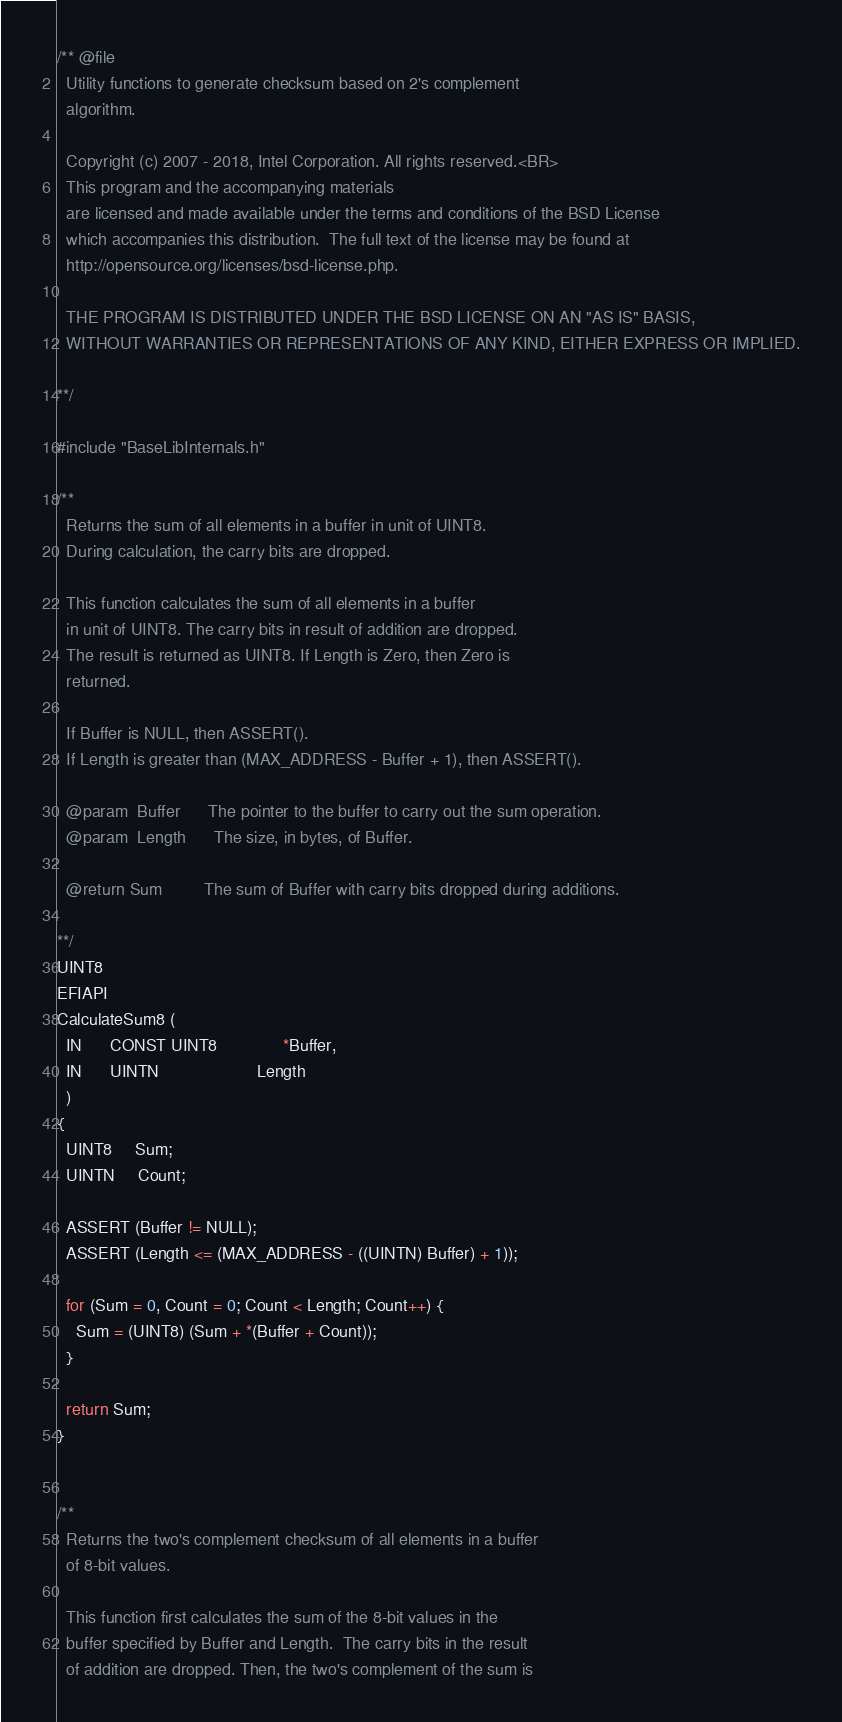<code> <loc_0><loc_0><loc_500><loc_500><_C_>/** @file
  Utility functions to generate checksum based on 2's complement
  algorithm.

  Copyright (c) 2007 - 2018, Intel Corporation. All rights reserved.<BR>
  This program and the accompanying materials
  are licensed and made available under the terms and conditions of the BSD License
  which accompanies this distribution.  The full text of the license may be found at
  http://opensource.org/licenses/bsd-license.php.

  THE PROGRAM IS DISTRIBUTED UNDER THE BSD LICENSE ON AN "AS IS" BASIS,
  WITHOUT WARRANTIES OR REPRESENTATIONS OF ANY KIND, EITHER EXPRESS OR IMPLIED.

**/

#include "BaseLibInternals.h"

/**
  Returns the sum of all elements in a buffer in unit of UINT8.
  During calculation, the carry bits are dropped.

  This function calculates the sum of all elements in a buffer
  in unit of UINT8. The carry bits in result of addition are dropped.
  The result is returned as UINT8. If Length is Zero, then Zero is
  returned.

  If Buffer is NULL, then ASSERT().
  If Length is greater than (MAX_ADDRESS - Buffer + 1), then ASSERT().

  @param  Buffer      The pointer to the buffer to carry out the sum operation.
  @param  Length      The size, in bytes, of Buffer.

  @return Sum         The sum of Buffer with carry bits dropped during additions.

**/
UINT8
EFIAPI
CalculateSum8 (
  IN      CONST UINT8              *Buffer,
  IN      UINTN                     Length
  )
{
  UINT8     Sum;
  UINTN     Count;

  ASSERT (Buffer != NULL);
  ASSERT (Length <= (MAX_ADDRESS - ((UINTN) Buffer) + 1));

  for (Sum = 0, Count = 0; Count < Length; Count++) {
    Sum = (UINT8) (Sum + *(Buffer + Count));
  }

  return Sum;
}


/**
  Returns the two's complement checksum of all elements in a buffer
  of 8-bit values.

  This function first calculates the sum of the 8-bit values in the
  buffer specified by Buffer and Length.  The carry bits in the result
  of addition are dropped. Then, the two's complement of the sum is</code> 